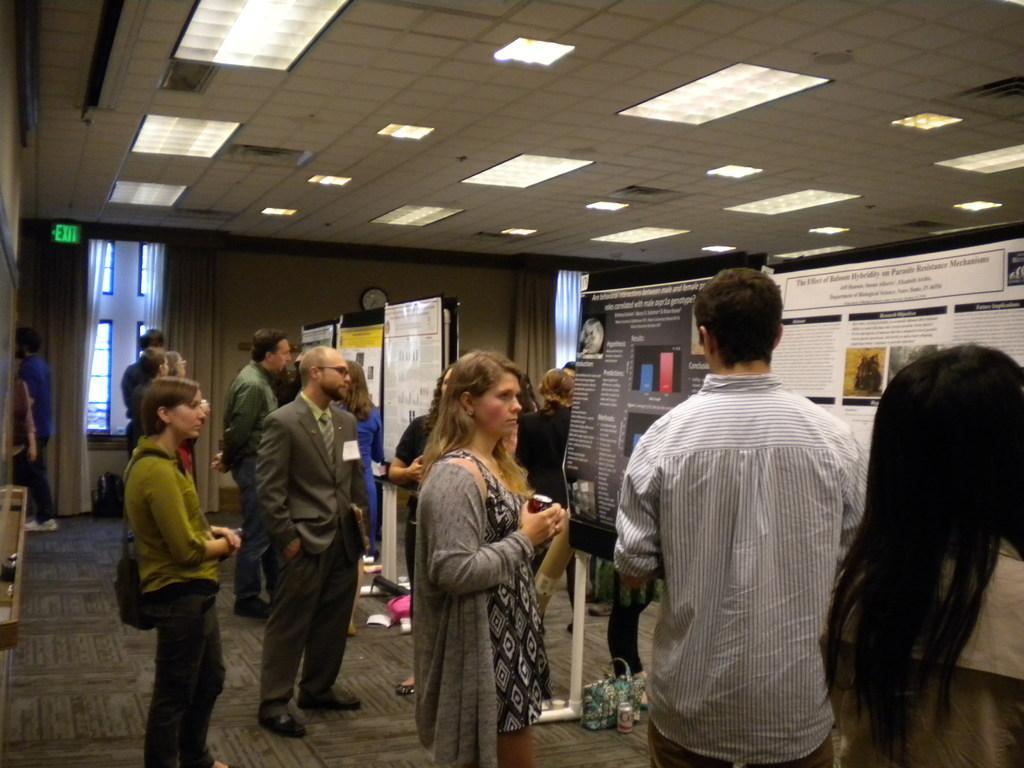Please provide a concise description of this image. In this image we can see a group of people are standing on the floor. Here we can see few posts. In the middle of the image, a woman is holding some object. Background there is a wall, few curtains, glass windows. Top of the image, there is a roof with lights. Here we can see clock and sign board. There are so many things and objects are placed here. 